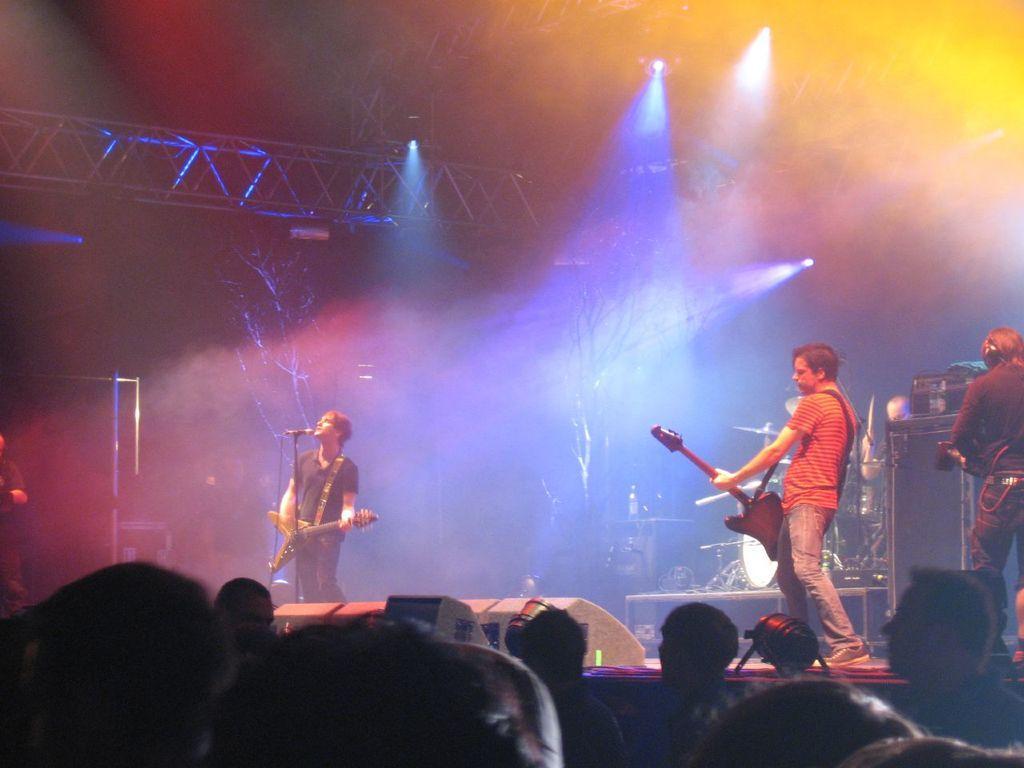Can you describe this image briefly? There is a stage. On the stage there are speakers. Also two persons are playing guitar. In front of one person there is a mic with mic stand. On the top there are lights. In the back there are drums and many other items on the stage. In front of the stage there are many people. 